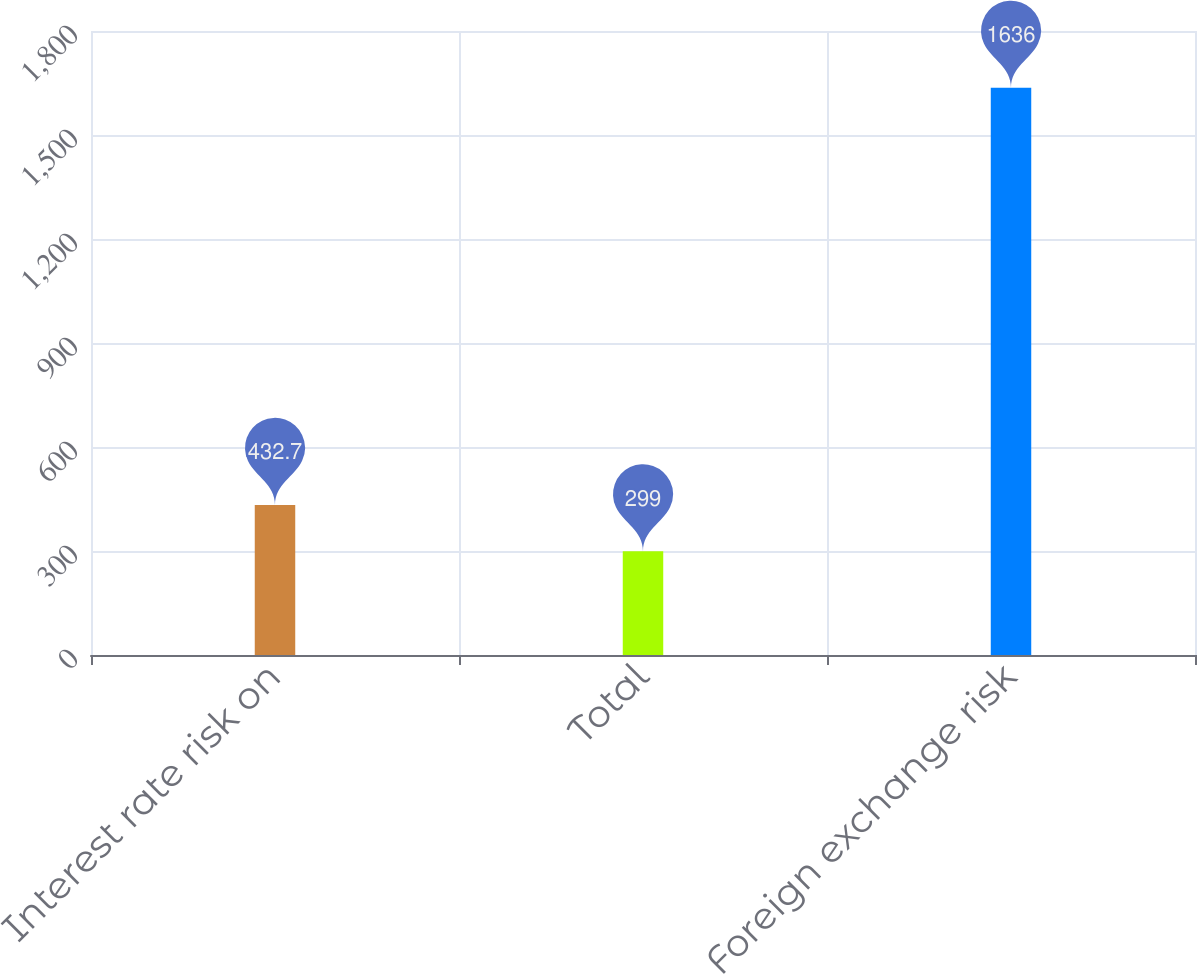<chart> <loc_0><loc_0><loc_500><loc_500><bar_chart><fcel>Interest rate risk on<fcel>Total<fcel>Foreign exchange risk<nl><fcel>432.7<fcel>299<fcel>1636<nl></chart> 